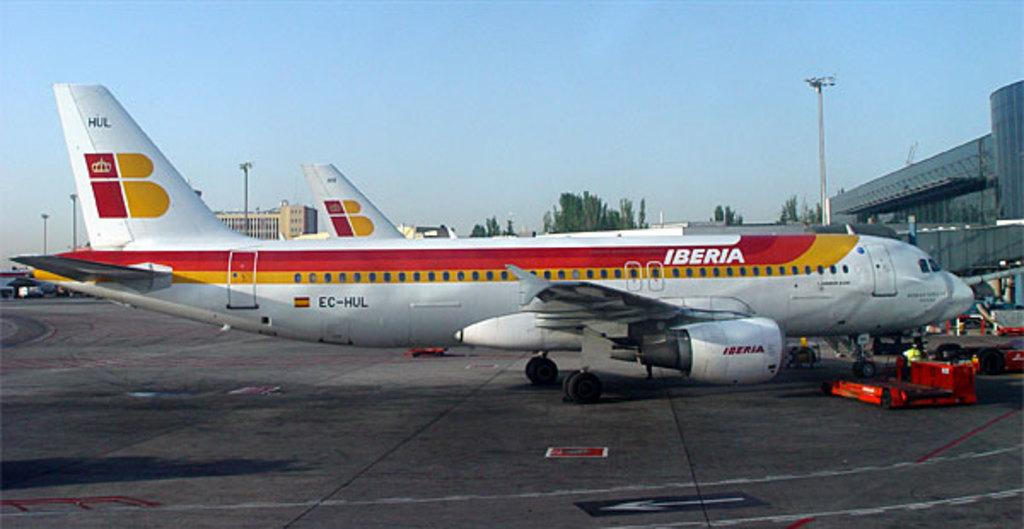<image>
Write a terse but informative summary of the picture. Two Iberian airplanes are parked at an airline terminal. 